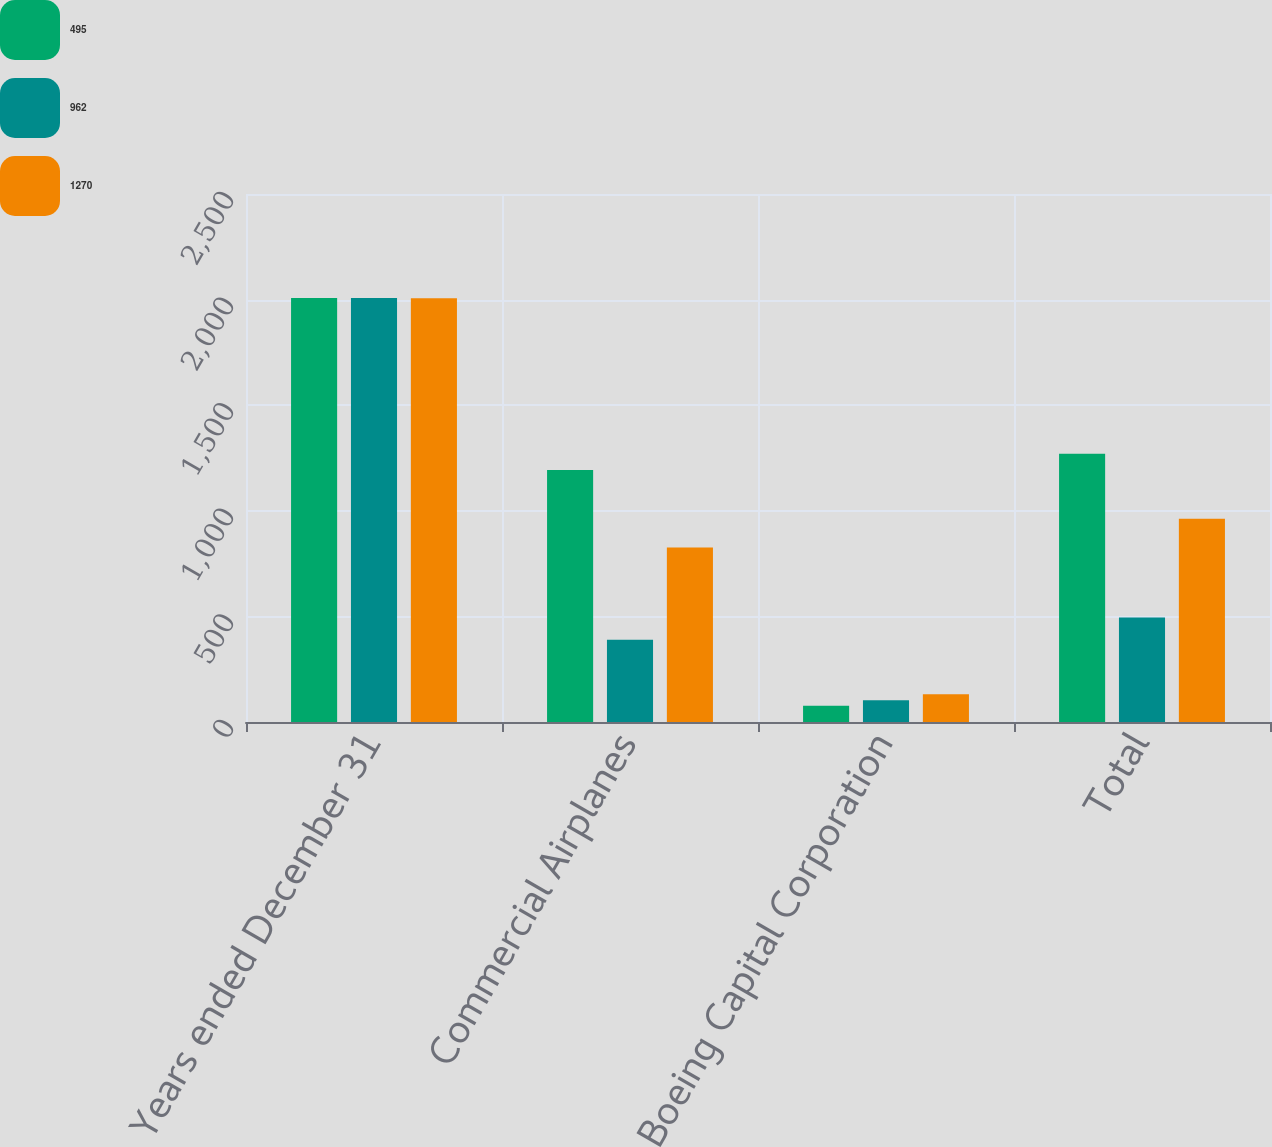Convert chart to OTSL. <chart><loc_0><loc_0><loc_500><loc_500><stacked_bar_chart><ecel><fcel>Years ended December 31<fcel>Commercial Airplanes<fcel>Boeing Capital Corporation<fcel>Total<nl><fcel>495<fcel>2008<fcel>1193<fcel>77<fcel>1270<nl><fcel>962<fcel>2007<fcel>390<fcel>103<fcel>495<nl><fcel>1270<fcel>2006<fcel>826<fcel>131<fcel>962<nl></chart> 